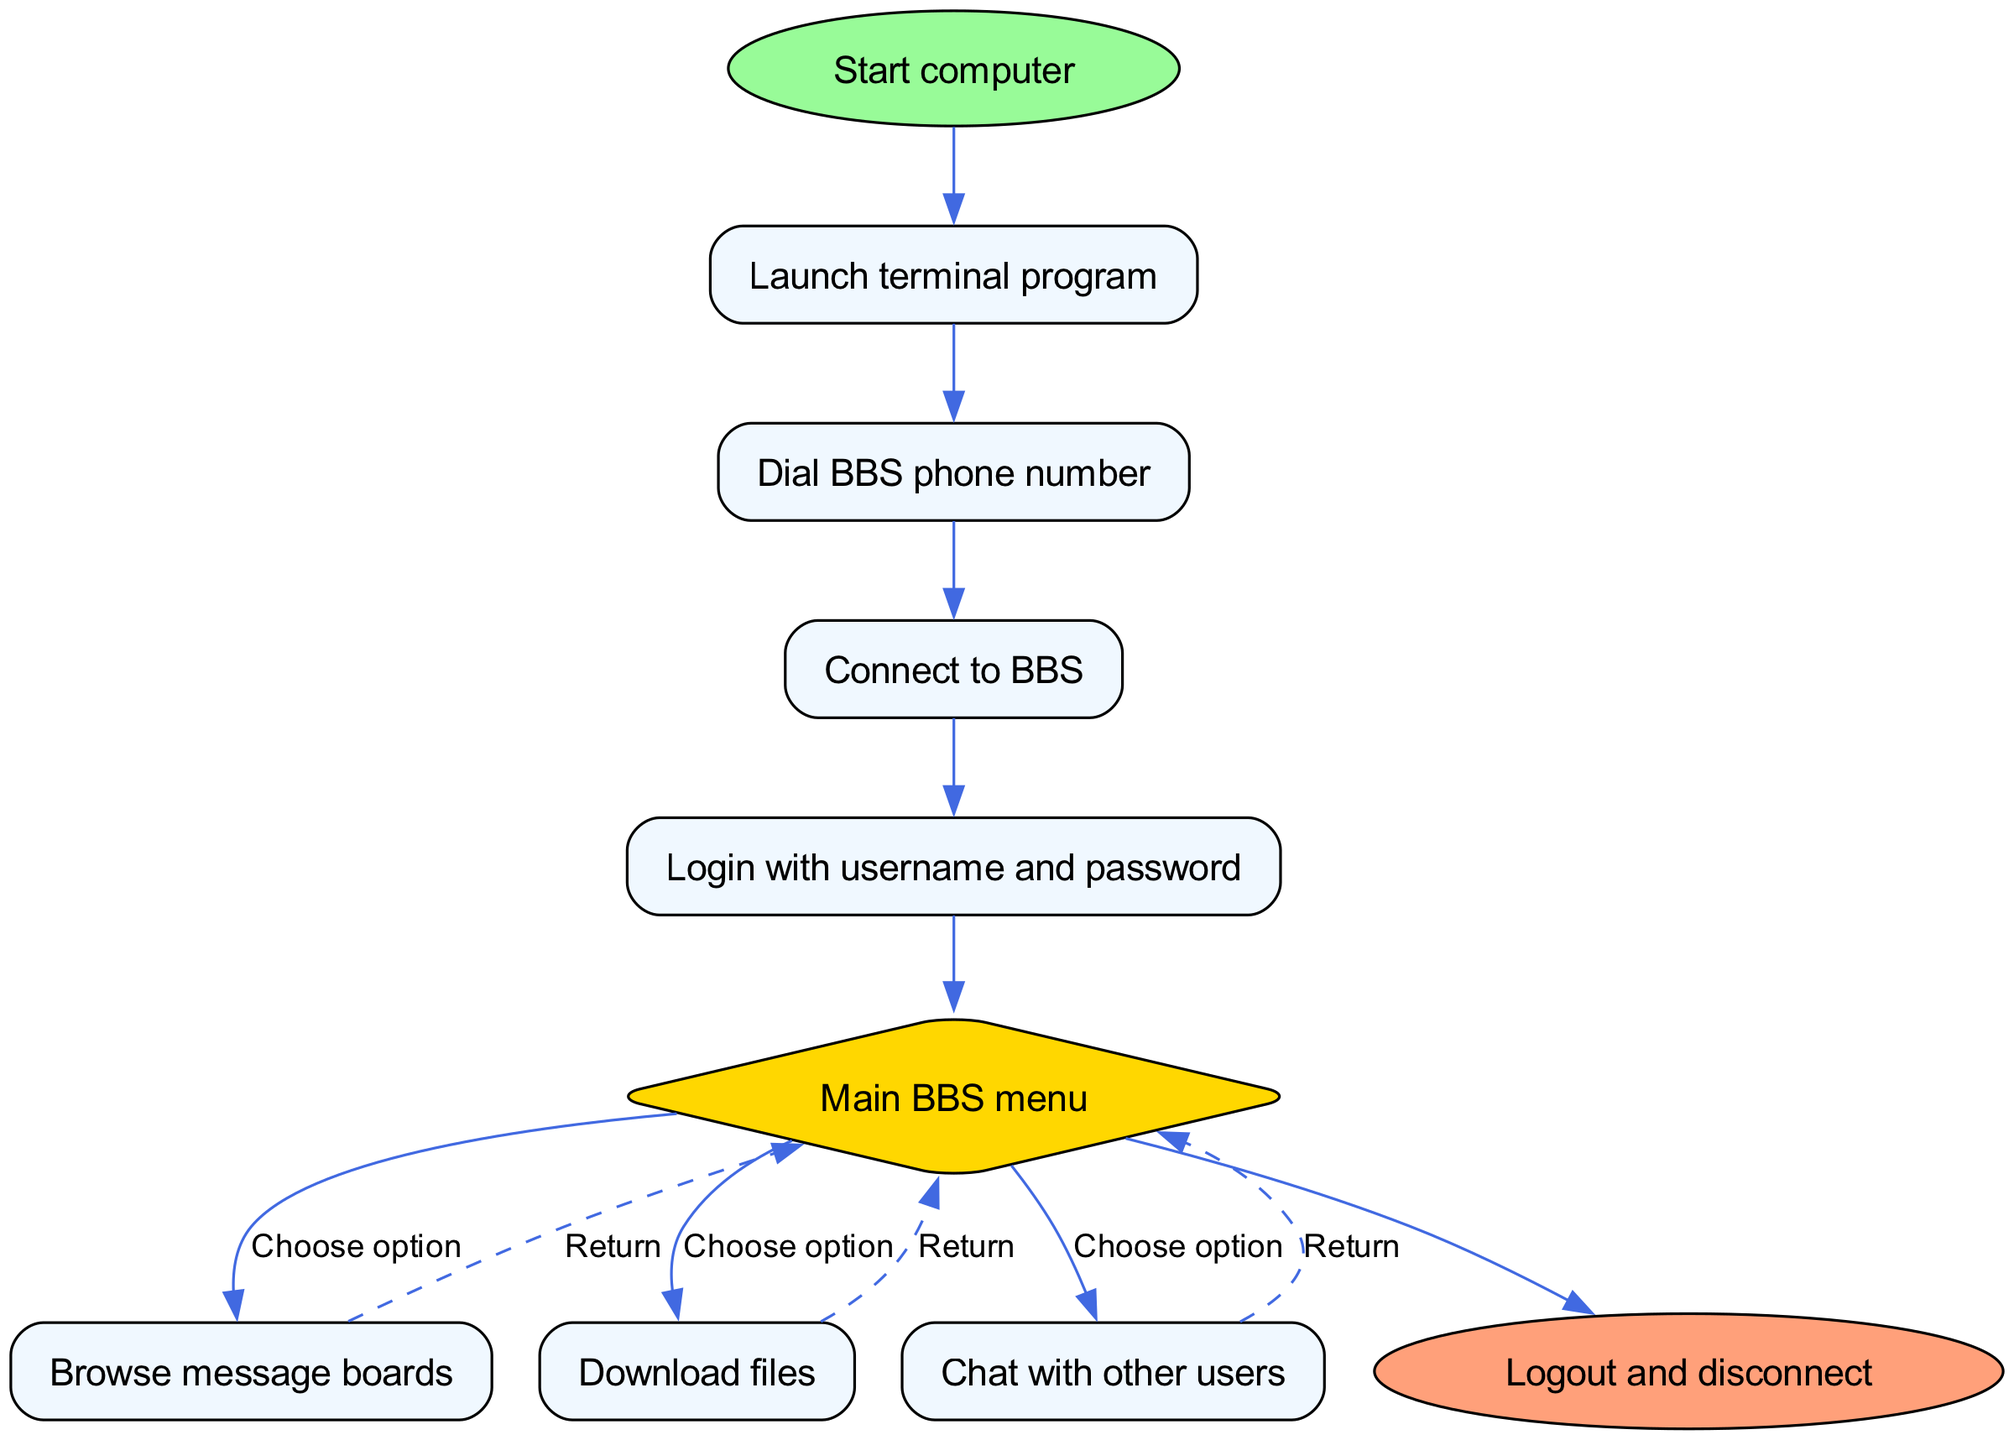What is the first step in the diagram? The first step in the diagram is represented by the first node, which starts the process of connecting to a bulletin board system. It is indicated as "Start computer."
Answer: Start computer What color is the node "Main BBS menu"? The node "Main BBS menu" is represented as a diamond shape filled with yellow color, designated in the diagram's attributes.
Answer: Yellow How many edges are there leading from the "Main BBS menu"? The "Main BBS menu" has three outgoing edges leading to the options for browsing boards, downloading files, and chatting with other users. These connections allow the user to interact with the menu options effectively.
Answer: Three What do you do after logging in with your username and password? After logging in, the next step indicated in the flowchart is going to the "Main BBS menu," where you can choose from various activities available on the bulletin board system.
Answer: Main BBS menu If you choose to browse message boards, what is the next action available? After browsing message boards, the flowchart shows an edge that leads back to the "Main BBS menu," indicating that users can return to the main menu after browsing. This is part of the flow process.
Answer: Return What is the last step before disconnecting from the BBS? The last step before disconnecting from the BBS as represented in the diagram is "Logout and disconnect," which signifies the end of the user's session on the bulletin board system.
Answer: Logout and disconnect What action does a user take after downloading files? After downloading files, the user can choose to return to the "Main BBS menu," as indicated by the flow that connects download actions back to the main menu options.
Answer: Return How many options are available in the "Main BBS menu"? The "Main BBS menu" provides three options: browse message boards, download files, and chat with other users, allowing users varied interactions after logging in.
Answer: Three 